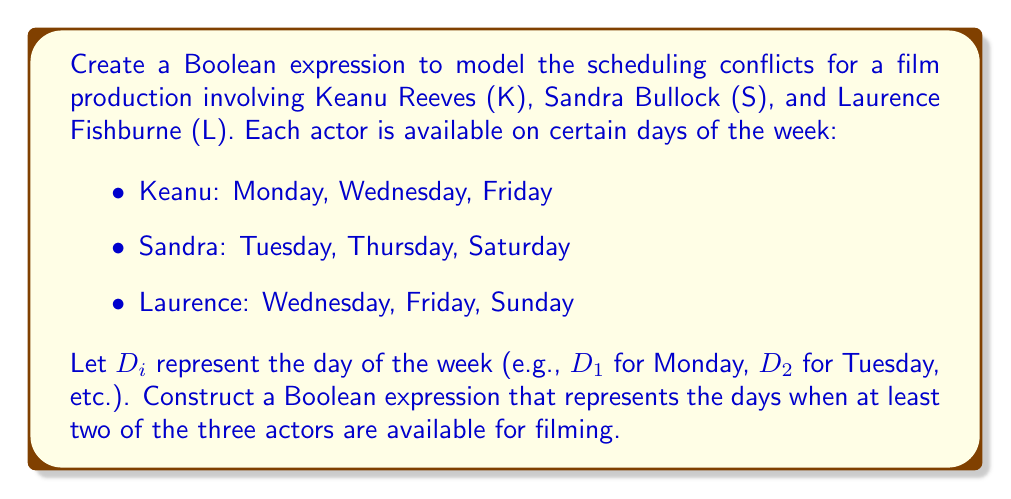Can you solve this math problem? To solve this problem, we'll follow these steps:

1. Express each actor's availability as a Boolean expression:
   Keanu (K): $K = D_1 + D_3 + D_5$
   Sandra (S): $S = D_2 + D_4 + D_6$
   Laurence (L): $L = D_3 + D_5 + D_7$

2. We need to find the days when at least two actors are available. This can be represented as:
   $(K \cdot S) + (K \cdot L) + (S \cdot L)$

3. Substitute the expressions for K, S, and L:
   $((D_1 + D_3 + D_5) \cdot (D_2 + D_4 + D_6)) + ((D_1 + D_3 + D_5) \cdot (D_3 + D_5 + D_7)) + ((D_2 + D_4 + D_6) \cdot (D_3 + D_5 + D_7))$

4. Distribute the terms:
   $(D_1D_2 + D_1D_4 + D_1D_6 + D_3D_2 + D_3D_4 + D_3D_6 + D_5D_2 + D_5D_4 + D_5D_6) + (D_1D_3 + D_1D_5 + D_1D_7 + D_3D_3 + D_3D_5 + D_3D_7 + D_5D_3 + D_5D_5 + D_5D_7) + (D_2D_3 + D_2D_5 + D_2D_7 + D_4D_3 + D_4D_5 + D_4D_7 + D_6D_3 + D_6D_5 + D_6D_7)$

5. Simplify by removing impossible combinations (e.g., $D_1D_2$) and redundant terms:
   $(D_3 + D_5) + (D_3 + D_5) + (D_3 + D_5)$

6. Further simplify:
   $D_3 + D_5$

This final expression represents the days when at least two of the three actors are available for filming.
Answer: $D_3 + D_5$ 